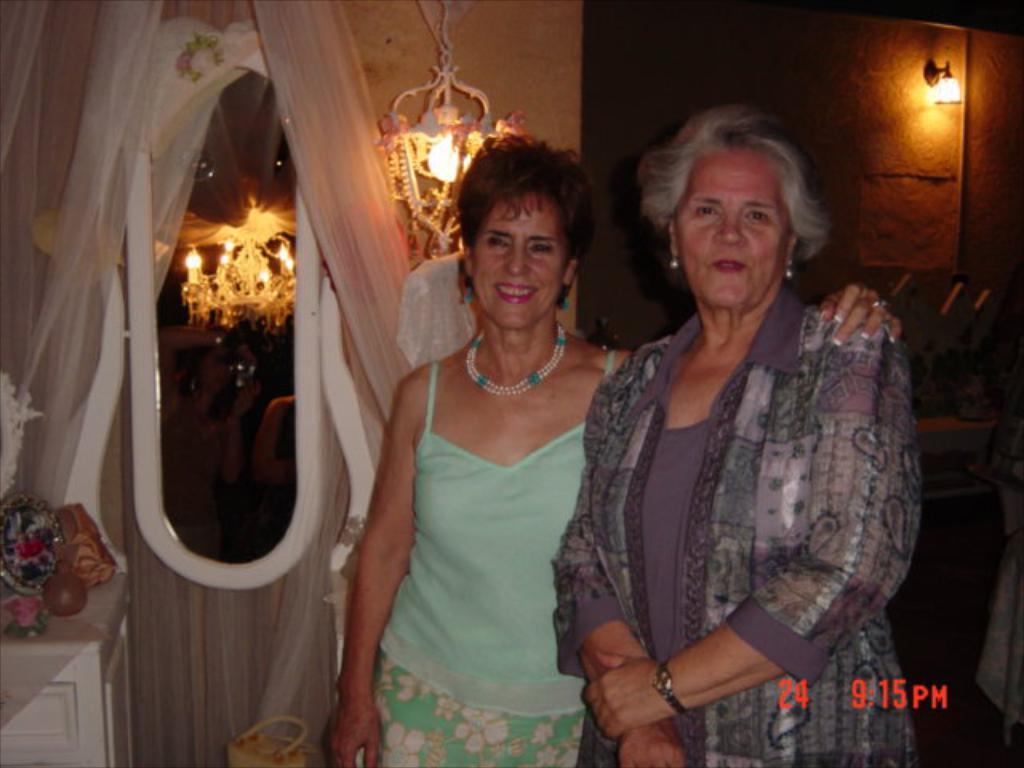How many women are in the image? There are two women in the image. What is the facial expression of the women? The women are smiling. What is present on the wall in the image? There is a wall in the image, but no specific details are mentioned about what is on the wall. What type of window treatment is visible in the image? There are curtains in the image. What type of lighting fixture is present in the image? There is a chandelier in the image. What type of lighting is present in the image? There are lights in the image. What other objects can be seen in the image? There are some objects in the image, but no specific details are mentioned about what these objects are. What type of text is visible in the image? There is some text visible in the image, but no specific details are mentioned about what the text says. How many bears are visible in the image? There are no bears present in the image. What is the women's attention focused on in the image? The provided facts do not mention what the women are paying attention to in the image. 